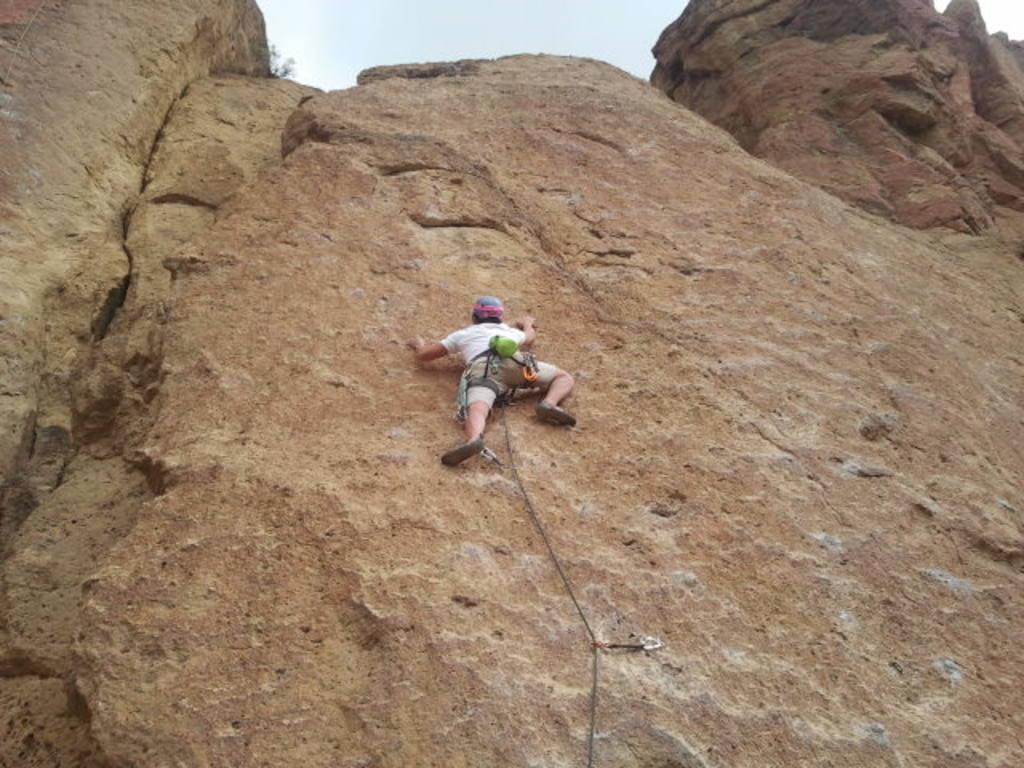Describe this image in one or two sentences. In the center of the image we can see a person climbing a rock. In the background there is sky. 